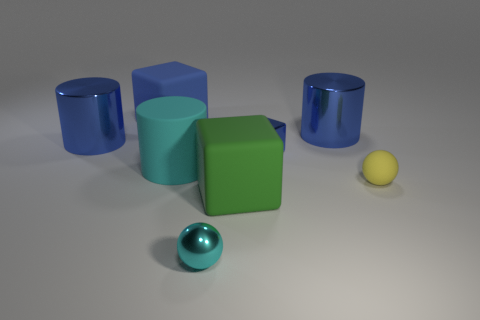There is a small cube; is it the same color as the small sphere on the right side of the metal block?
Your answer should be compact. No. There is a large blue object that is both on the left side of the blue metal block and in front of the blue rubber thing; what is its material?
Make the answer very short. Metal. There is a rubber cylinder that is the same color as the metal sphere; what size is it?
Offer a terse response. Large. Is the shape of the small metal thing that is in front of the yellow rubber sphere the same as the large shiny thing right of the small cyan object?
Your answer should be very brief. No. Are there any yellow balls?
Make the answer very short. Yes. What color is the shiny thing that is the same shape as the large blue rubber object?
Keep it short and to the point. Blue. What is the color of the metallic sphere that is the same size as the yellow thing?
Your answer should be very brief. Cyan. Does the large blue block have the same material as the small blue thing?
Ensure brevity in your answer.  No. What number of balls have the same color as the large matte cylinder?
Ensure brevity in your answer.  1. Is the small rubber thing the same color as the metallic block?
Keep it short and to the point. No. 